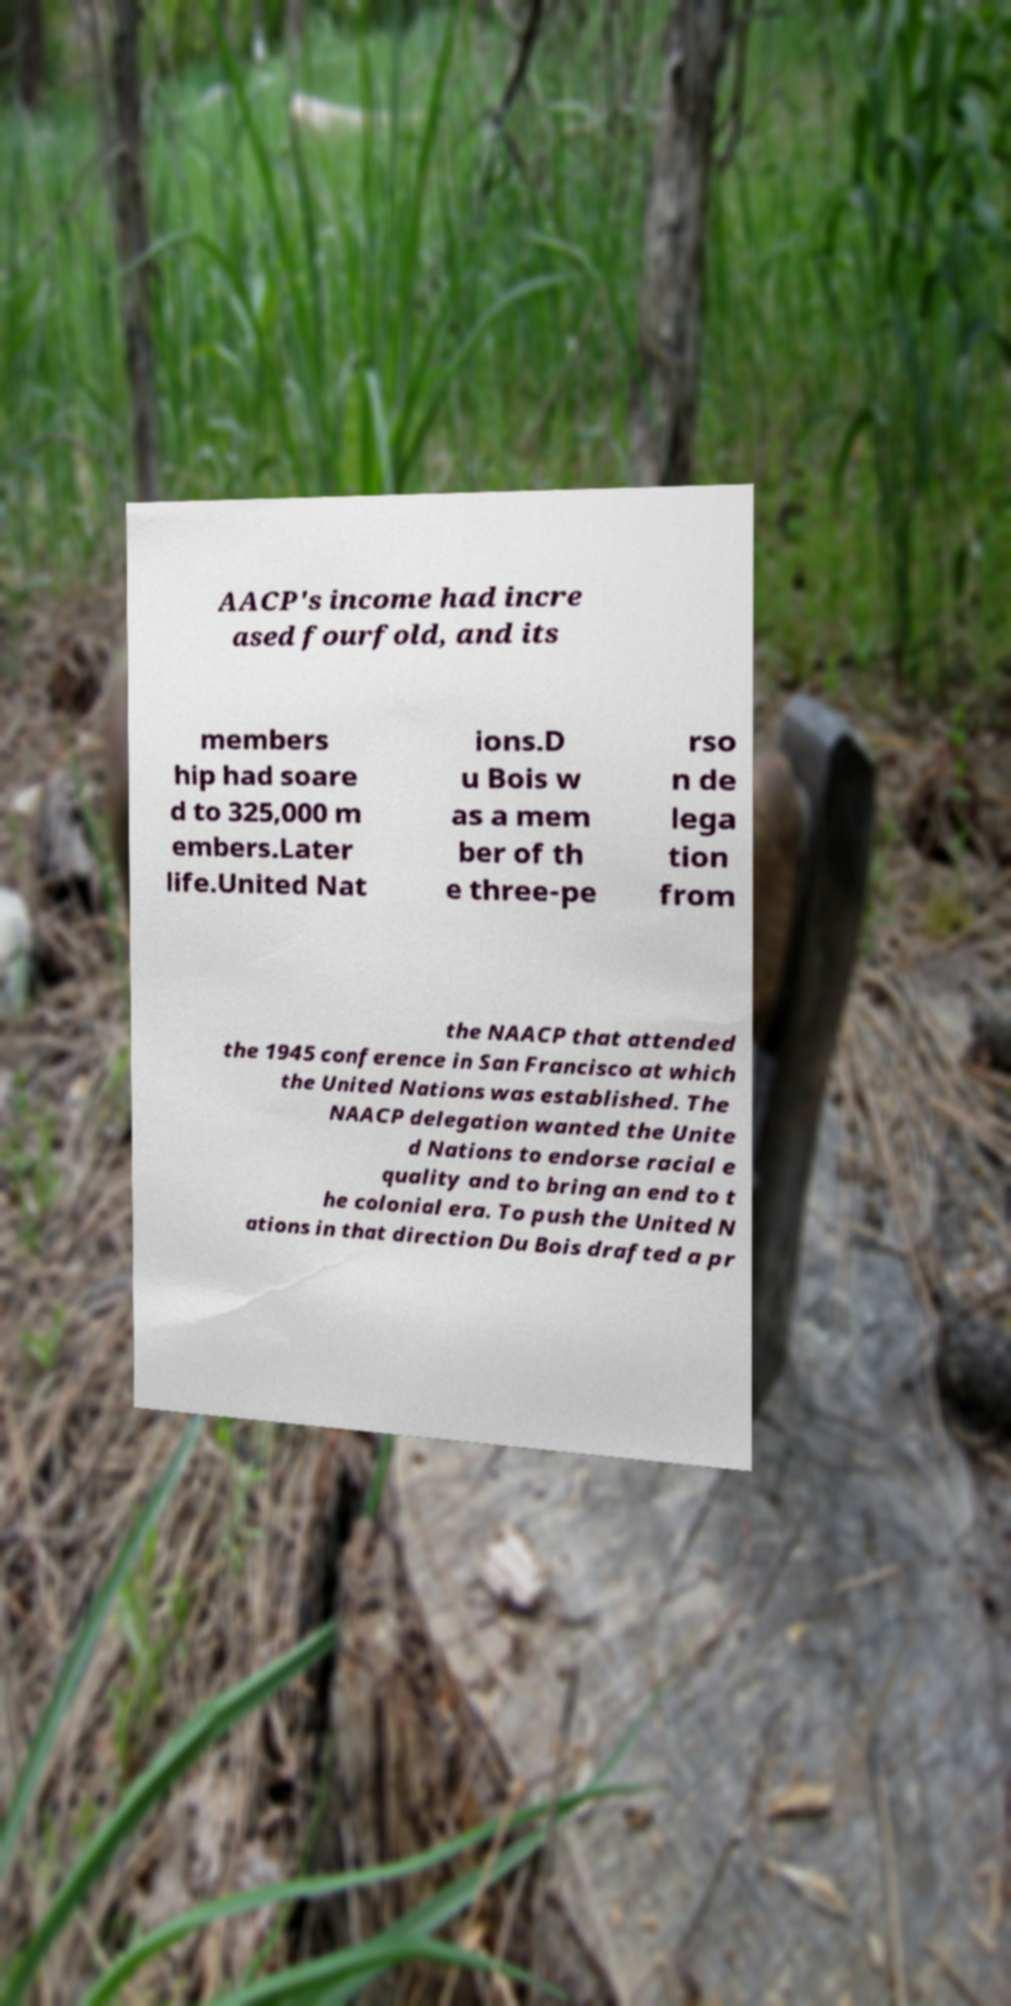Please identify and transcribe the text found in this image. AACP's income had incre ased fourfold, and its members hip had soare d to 325,000 m embers.Later life.United Nat ions.D u Bois w as a mem ber of th e three-pe rso n de lega tion from the NAACP that attended the 1945 conference in San Francisco at which the United Nations was established. The NAACP delegation wanted the Unite d Nations to endorse racial e quality and to bring an end to t he colonial era. To push the United N ations in that direction Du Bois drafted a pr 